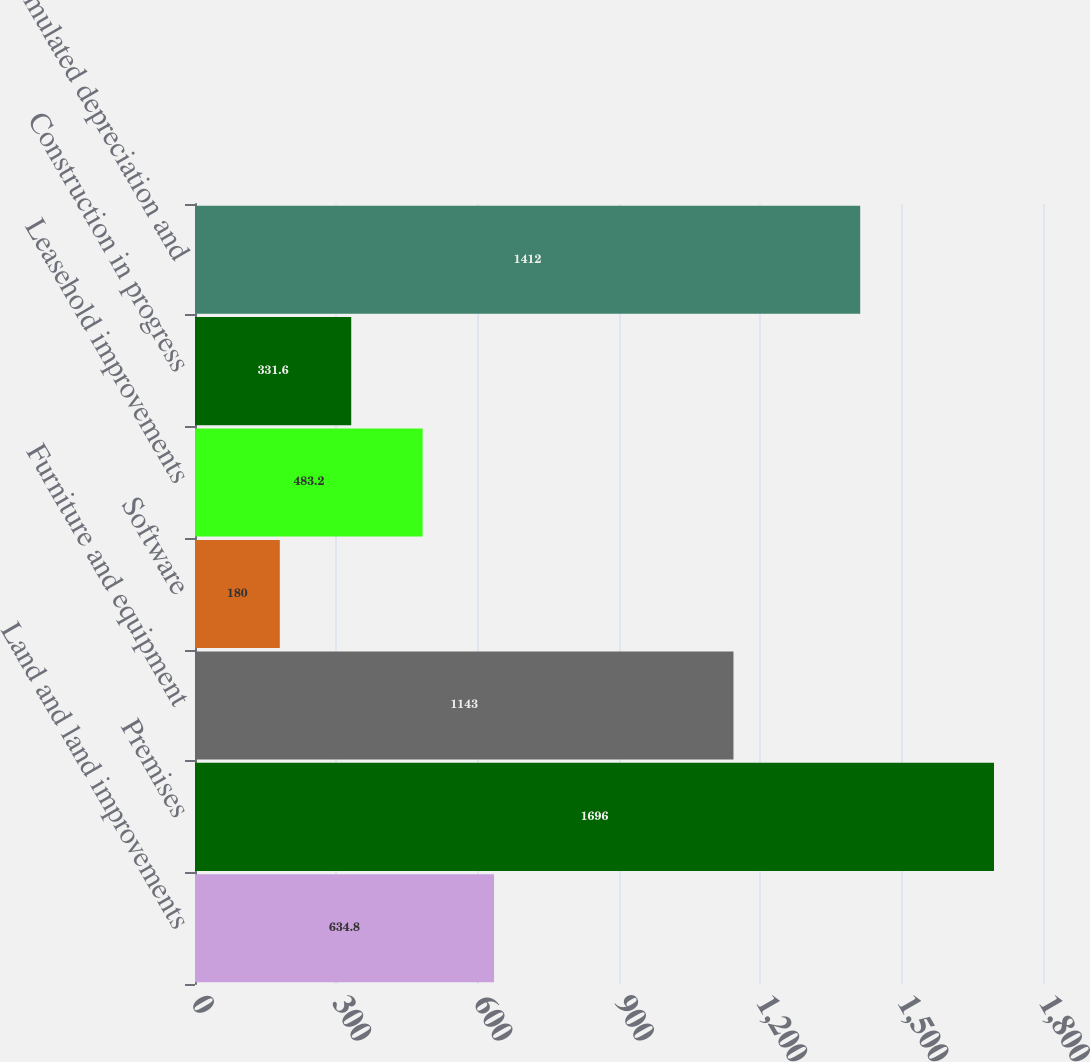Convert chart to OTSL. <chart><loc_0><loc_0><loc_500><loc_500><bar_chart><fcel>Land and land improvements<fcel>Premises<fcel>Furniture and equipment<fcel>Software<fcel>Leasehold improvements<fcel>Construction in progress<fcel>Accumulated depreciation and<nl><fcel>634.8<fcel>1696<fcel>1143<fcel>180<fcel>483.2<fcel>331.6<fcel>1412<nl></chart> 